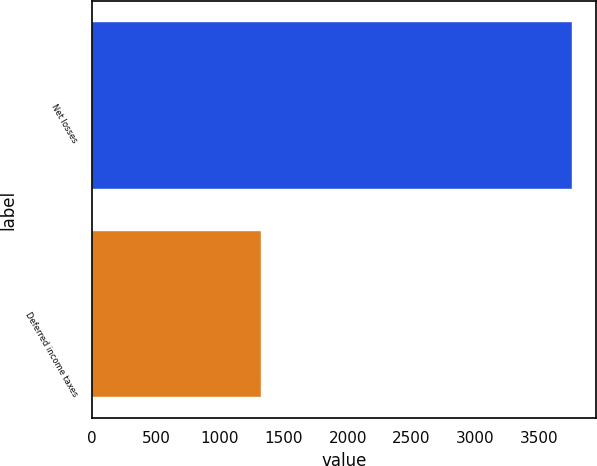Convert chart to OTSL. <chart><loc_0><loc_0><loc_500><loc_500><bar_chart><fcel>Net losses<fcel>Deferred income taxes<nl><fcel>3759<fcel>1318<nl></chart> 